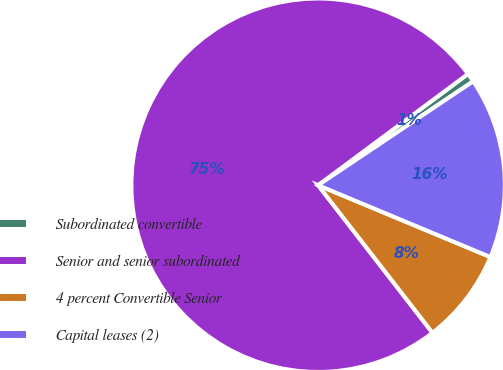Convert chart to OTSL. <chart><loc_0><loc_0><loc_500><loc_500><pie_chart><fcel>Subordinated convertible<fcel>Senior and senior subordinated<fcel>4 percent Convertible Senior<fcel>Capital leases (2)<nl><fcel>0.77%<fcel>75.33%<fcel>8.22%<fcel>15.68%<nl></chart> 